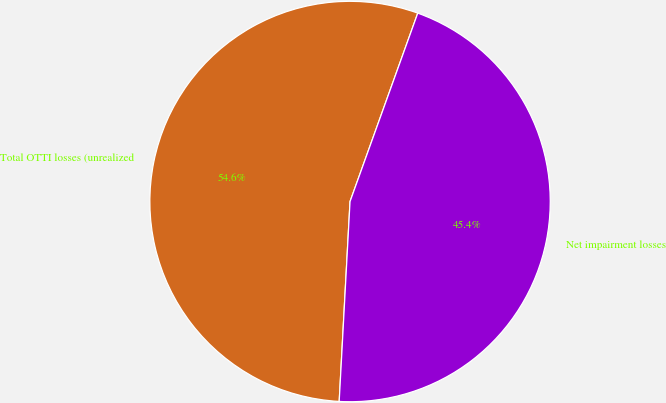Convert chart. <chart><loc_0><loc_0><loc_500><loc_500><pie_chart><fcel>Total OTTI losses (unrealized<fcel>Net impairment losses<nl><fcel>54.63%<fcel>45.37%<nl></chart> 